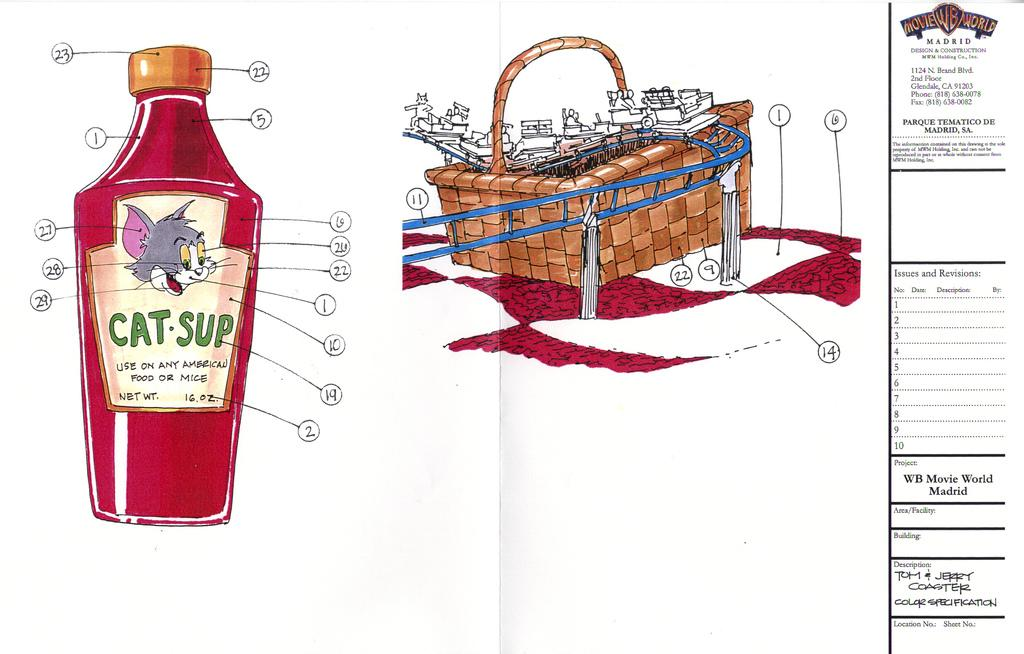<image>
Relay a brief, clear account of the picture shown. Drawing of a design that shots CatSup and a cartoon on it. 